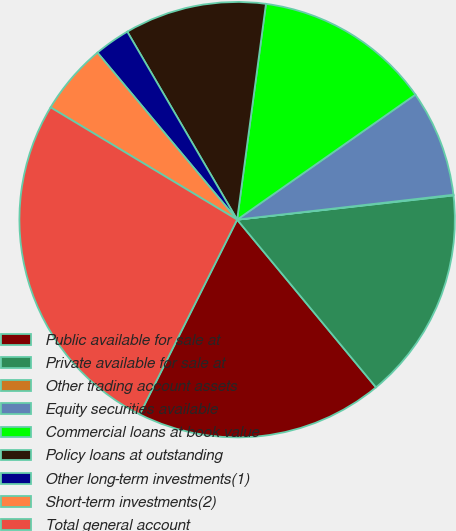<chart> <loc_0><loc_0><loc_500><loc_500><pie_chart><fcel>Public available for sale at<fcel>Private available for sale at<fcel>Other trading account assets<fcel>Equity securities available<fcel>Commercial loans at book value<fcel>Policy loans at outstanding<fcel>Other long-term investments(1)<fcel>Short-term investments(2)<fcel>Total general account<nl><fcel>18.39%<fcel>15.77%<fcel>0.05%<fcel>7.91%<fcel>13.15%<fcel>10.53%<fcel>2.67%<fcel>5.29%<fcel>26.24%<nl></chart> 